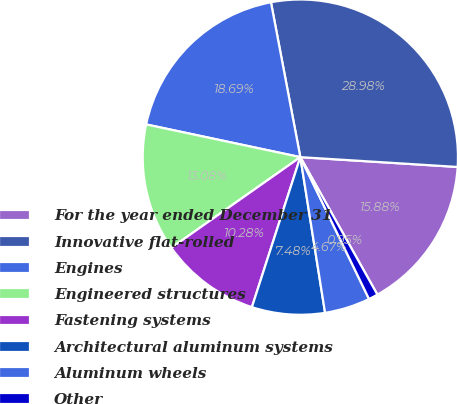<chart> <loc_0><loc_0><loc_500><loc_500><pie_chart><fcel>For the year ended December 31<fcel>Innovative flat-rolled<fcel>Engines<fcel>Engineered structures<fcel>Fastening systems<fcel>Architectural aluminum systems<fcel>Aluminum wheels<fcel>Other<nl><fcel>15.88%<fcel>28.98%<fcel>18.69%<fcel>13.08%<fcel>10.28%<fcel>7.48%<fcel>4.67%<fcel>0.95%<nl></chart> 